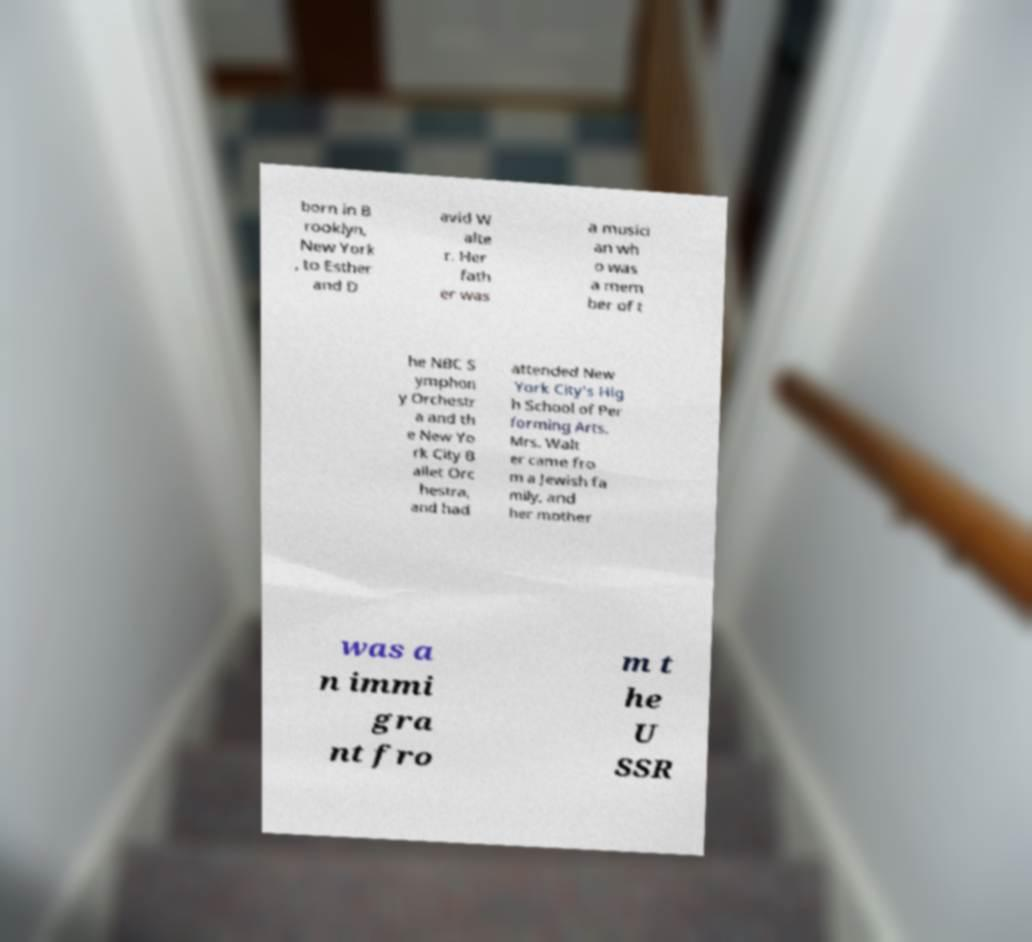Can you read and provide the text displayed in the image?This photo seems to have some interesting text. Can you extract and type it out for me? born in B rooklyn, New York , to Esther and D avid W alte r. Her fath er was a musici an wh o was a mem ber of t he NBC S ymphon y Orchestr a and th e New Yo rk City B allet Orc hestra, and had attended New York City's Hig h School of Per forming Arts. Mrs. Walt er came fro m a Jewish fa mily, and her mother was a n immi gra nt fro m t he U SSR 